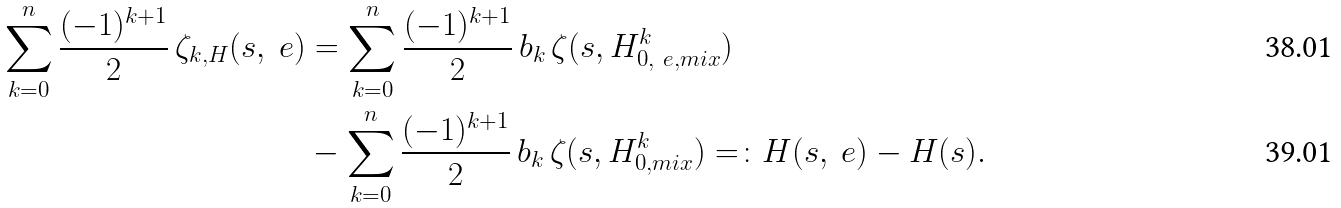Convert formula to latex. <formula><loc_0><loc_0><loc_500><loc_500>\sum _ { k = 0 } ^ { n } \frac { ( - 1 ) ^ { k + 1 } } { 2 } \, \zeta _ { k , H } ( s , \ e ) & = \sum _ { k = 0 } ^ { n } \frac { ( - 1 ) ^ { k + 1 } } { 2 } \, b _ { k } \, \zeta ( s , H ^ { k } _ { 0 , \ e , { m i x } } ) \\ & - \sum _ { k = 0 } ^ { n } \frac { ( - 1 ) ^ { k + 1 } } { 2 } \, b _ { k } \, \zeta ( s , H ^ { k } _ { 0 , { m i x } } ) = \colon H ( s , \ e ) - H ( s ) .</formula> 